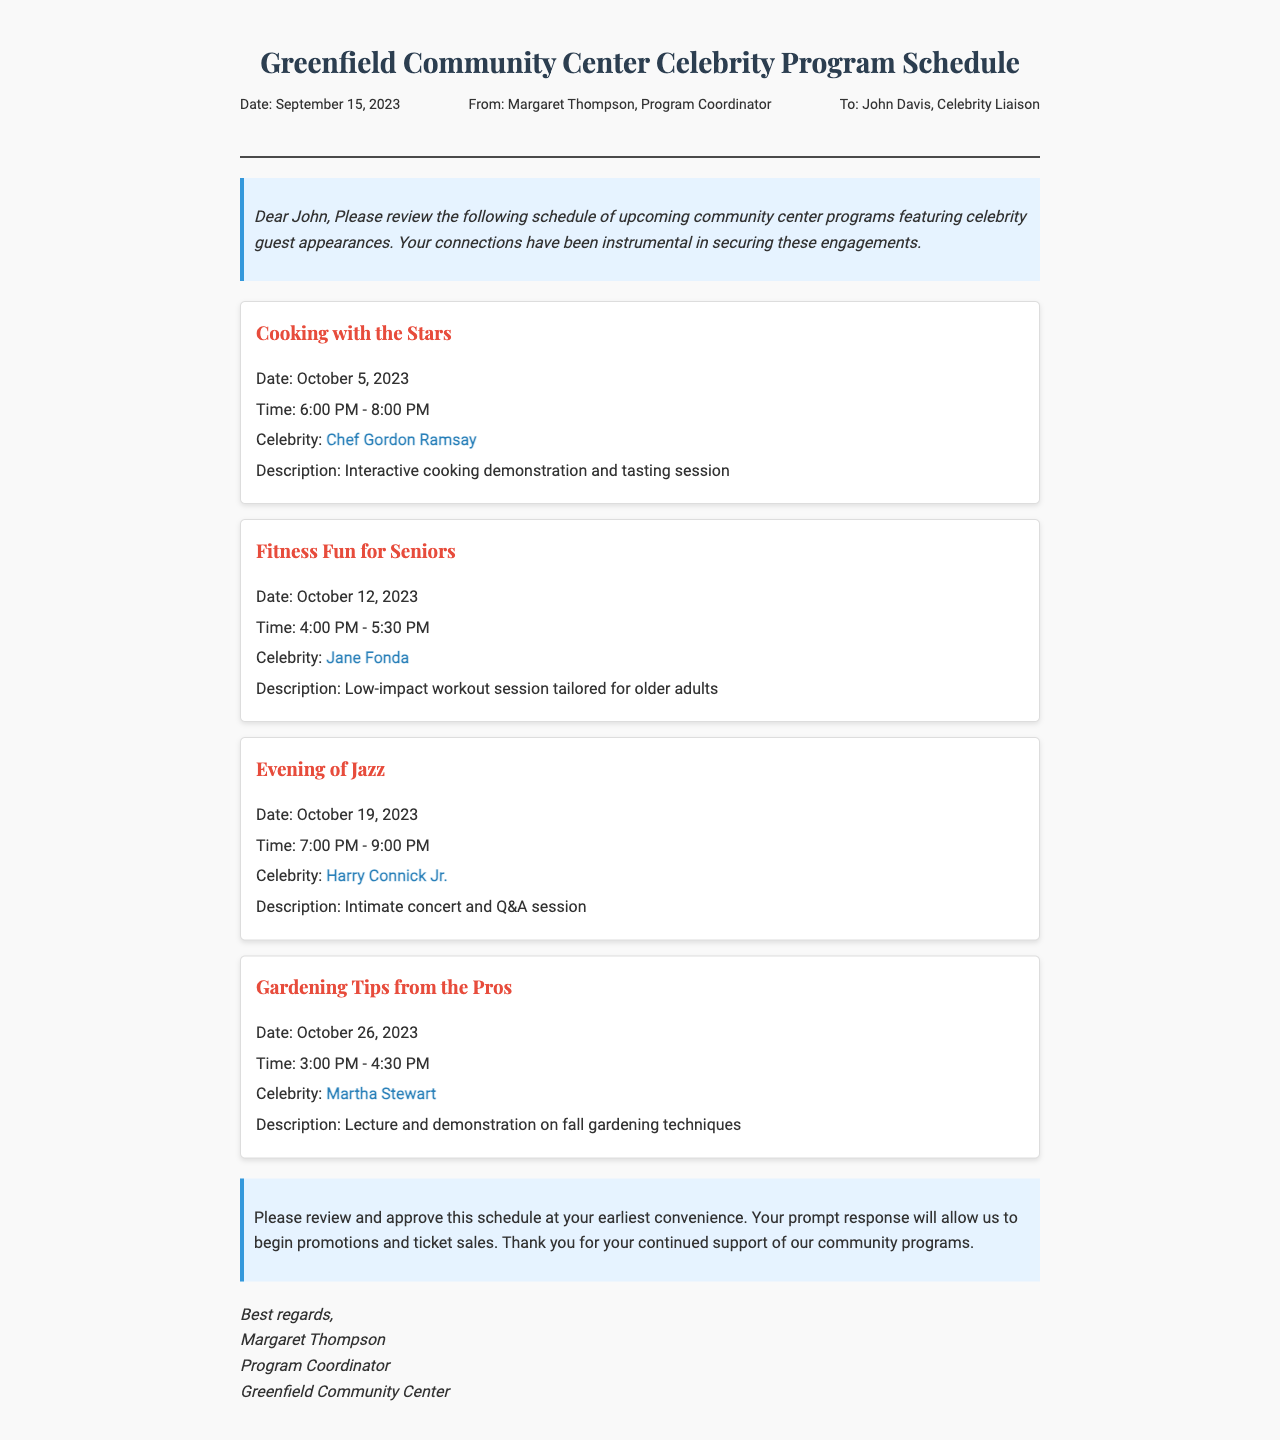What is the date of the Cooking with the Stars program? The date of the Cooking with the Stars program is specified in the document.
Answer: October 5, 2023 Who is the celebrity guest for the Fitness Fun for Seniors program? The document explicitly mentions the celebrity guest for the Fitness Fun for Seniors program.
Answer: Jane Fonda What time is the Evening of Jazz program scheduled to start? The start time is noted in the program details.
Answer: 7:00 PM How many programs feature celebrity chefs? By examining the document, we see there are multiple programs featuring celebrity chefs.
Answer: Two What is the main activity of the Gardening Tips from the Pros program? The document describes the focus of the Gardening Tips from the Pros program.
Answer: Lecture and demonstration Who is the sender of the fax? The sender's name is clearly indicated in the closing of the fax.
Answer: Margaret Thompson What is the purpose of this fax? The content of the introduction explains why the fax is being sent.
Answer: Review and approval What type of event is the Evening of Jazz? The document provides the nature of the Evening of Jazz program.
Answer: Concert and Q&A session 